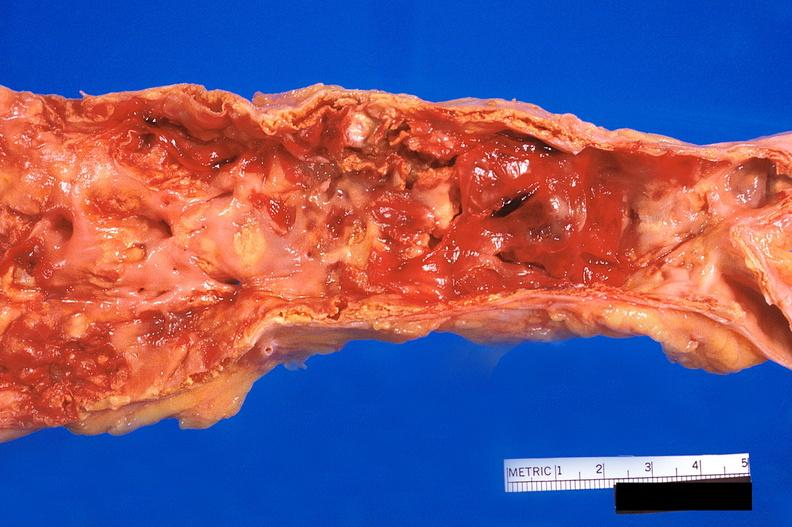s amyloidosis present?
Answer the question using a single word or phrase. No 